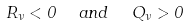<formula> <loc_0><loc_0><loc_500><loc_500>R _ { \nu } < 0 \ \ a n d \ \ Q _ { \nu } > 0</formula> 